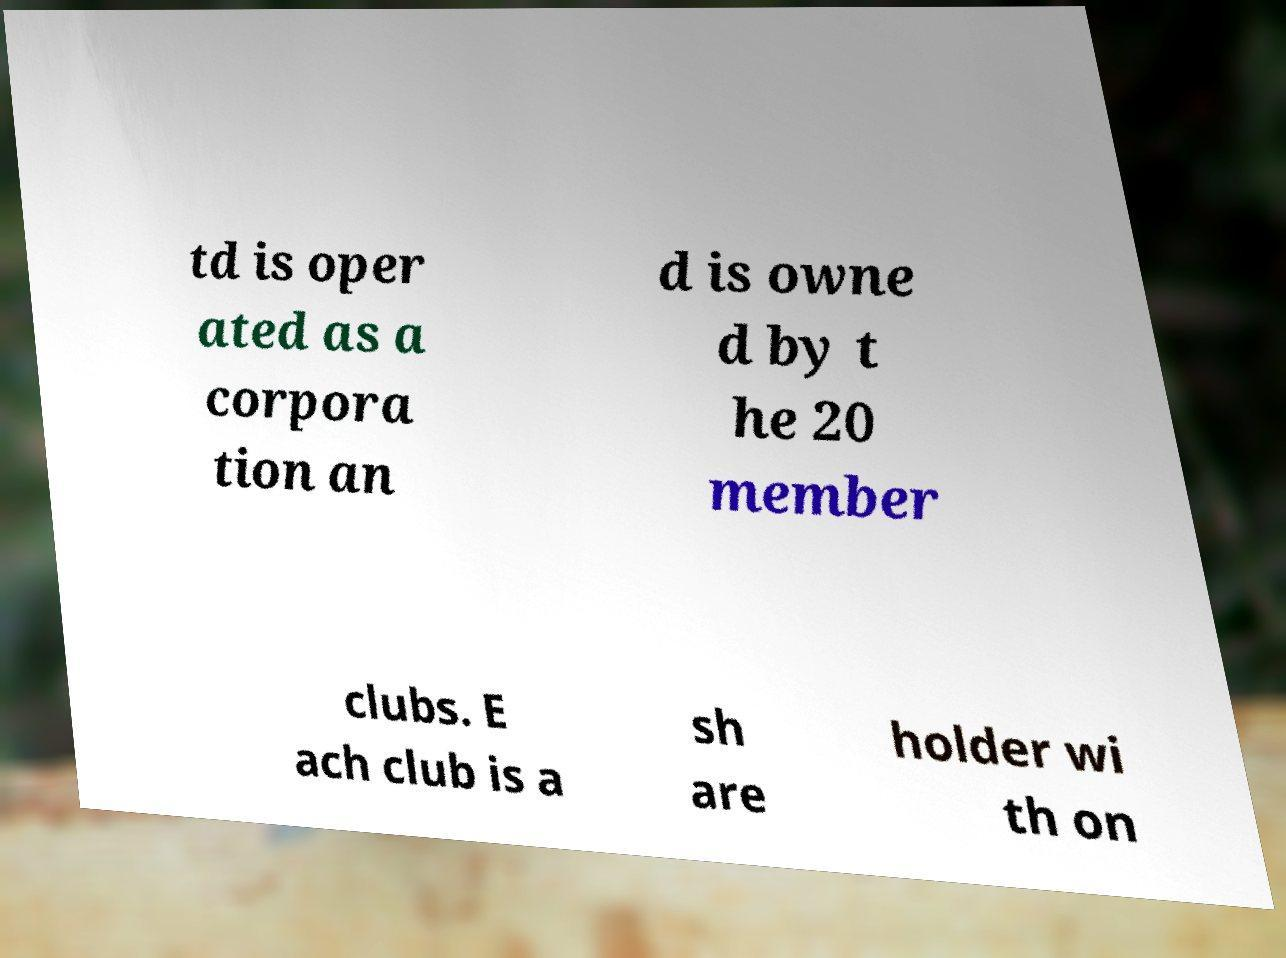Could you extract and type out the text from this image? td is oper ated as a corpora tion an d is owne d by t he 20 member clubs. E ach club is a sh are holder wi th on 